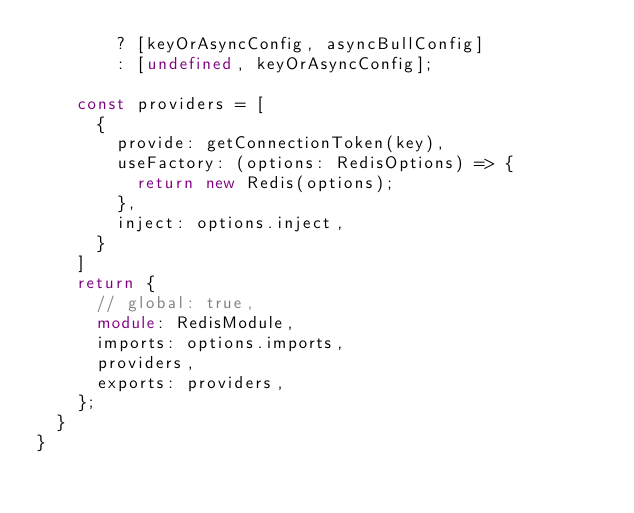Convert code to text. <code><loc_0><loc_0><loc_500><loc_500><_TypeScript_>        ? [keyOrAsyncConfig, asyncBullConfig]
        : [undefined, keyOrAsyncConfig];

    const providers = [
      {
        provide: getConnectionToken(key),
        useFactory: (options: RedisOptions) => {
          return new Redis(options);
        },
        inject: options.inject,
      }
    ]
    return {
      // global: true,
      module: RedisModule,
      imports: options.imports,
      providers,
      exports: providers,
    };
  }
}
</code> 